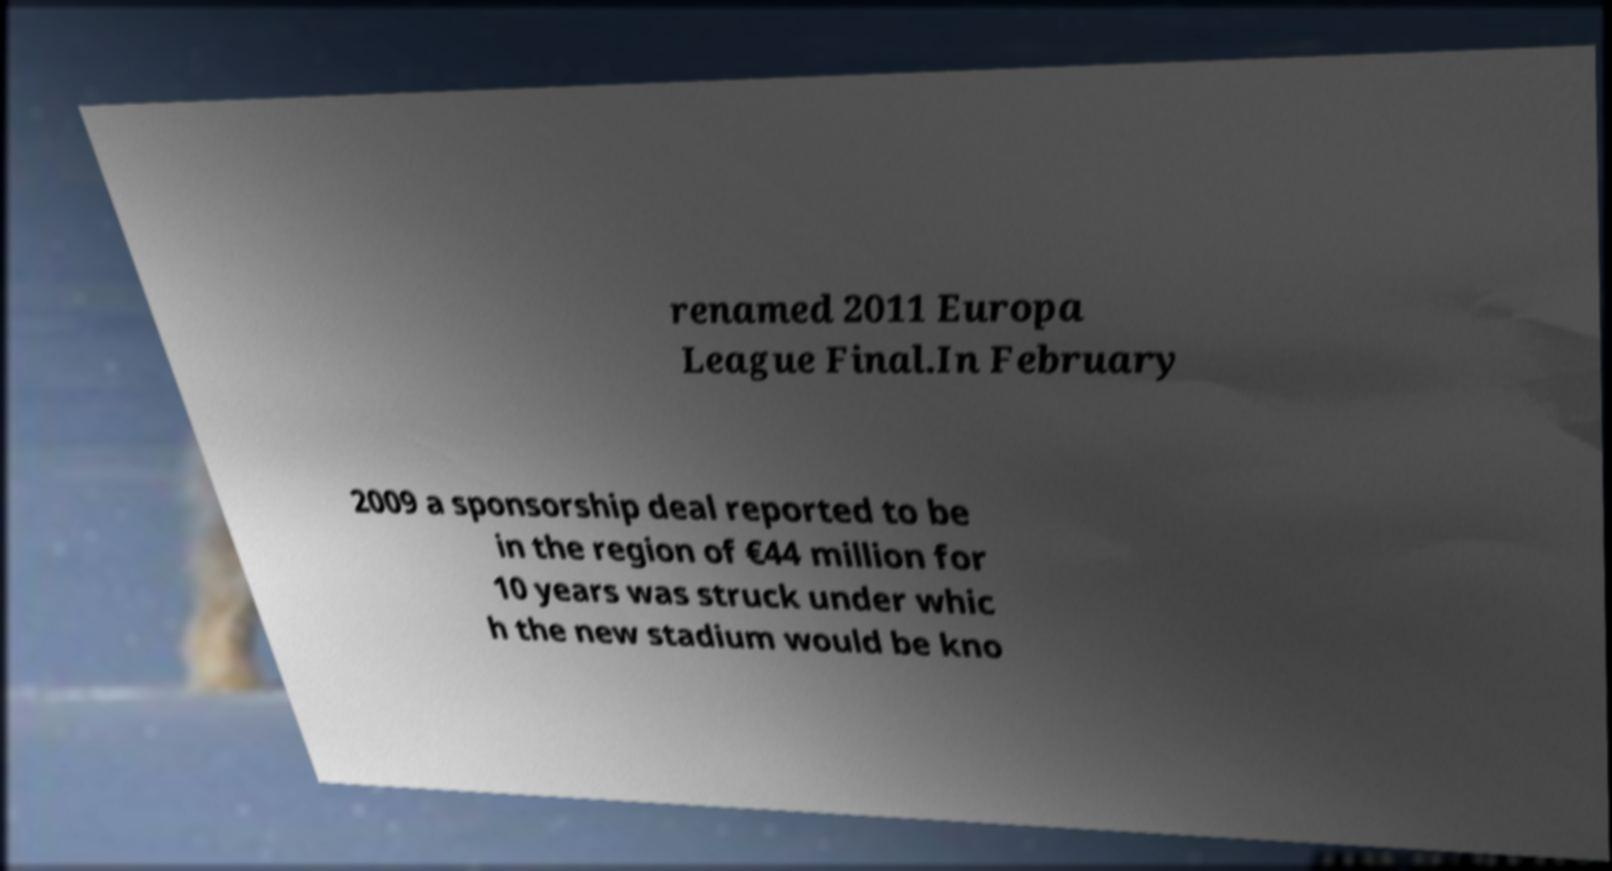Can you read and provide the text displayed in the image?This photo seems to have some interesting text. Can you extract and type it out for me? renamed 2011 Europa League Final.In February 2009 a sponsorship deal reported to be in the region of €44 million for 10 years was struck under whic h the new stadium would be kno 